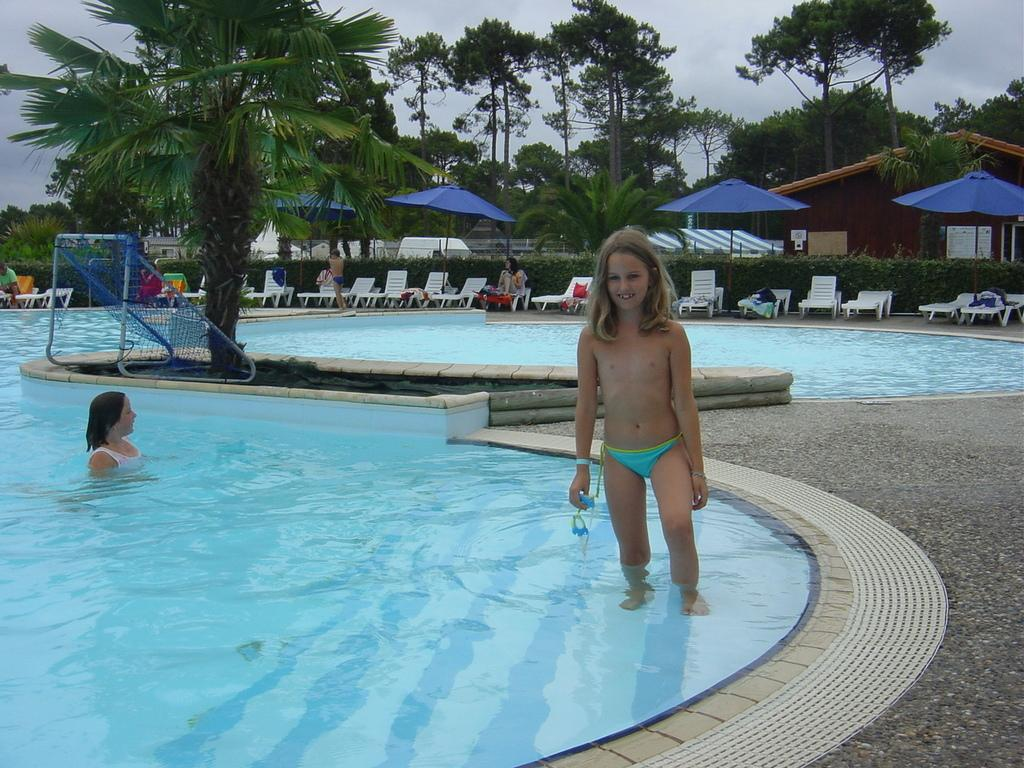How many persons are in the swimming pool in the image? There are two persons in the swimming pool in the image. What type of furniture is present in the image? There are chairs in the image. What type of shade is provided in the image? There are umbrellas in the image. What type of vegetation is present in the image? There are plants and trees in the image. What type of structure is visible in the image? There is a house in the image. How many other persons are visible in the image? There are other persons in the image. What is visible in the background of the image? The sky is visible in the background of the image. What type of quince is being served on the cake in the image? There is no cake or quince present in the image. Can you describe the worm crawling on the tree in the image? There are no worms visible in the image; only plants, trees, and a house are present. 